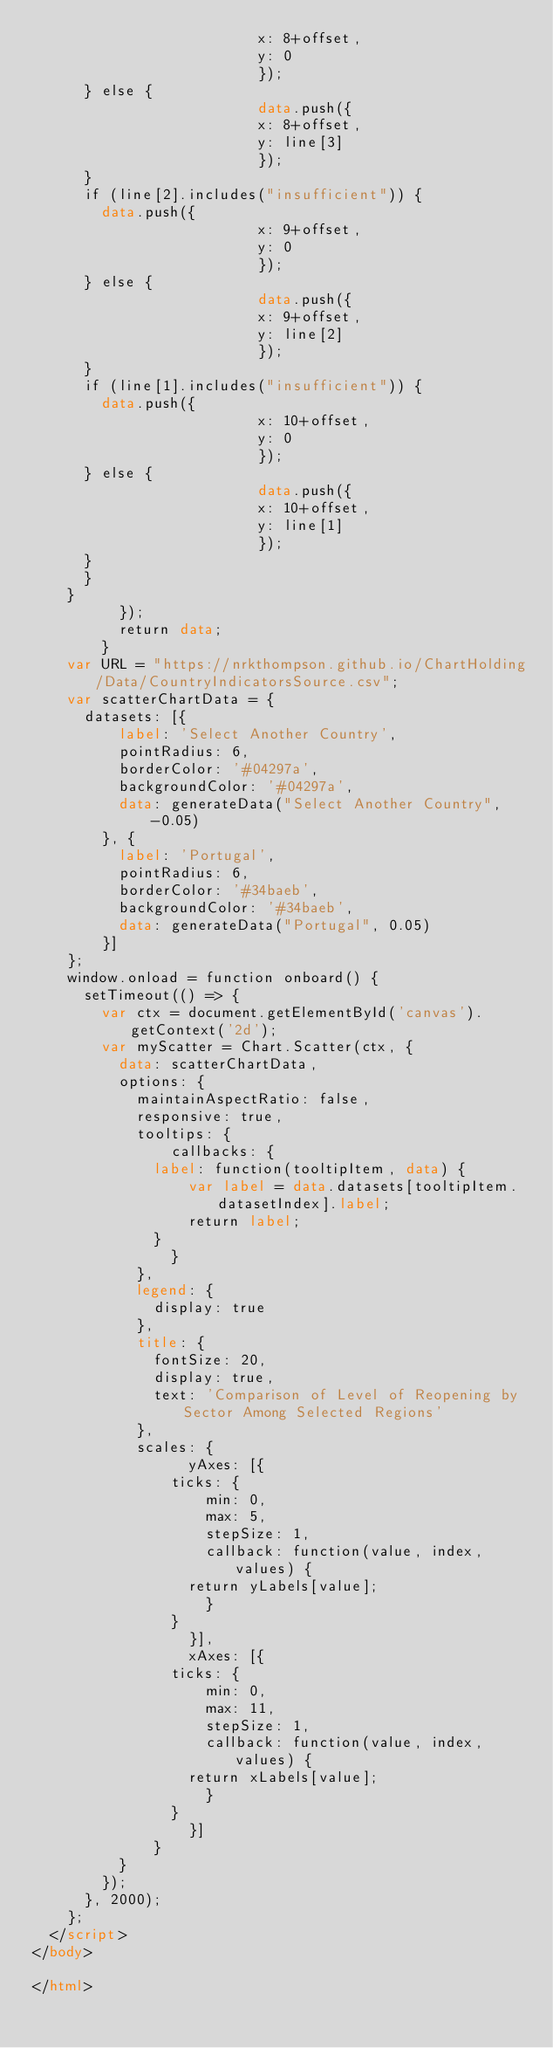Convert code to text. <code><loc_0><loc_0><loc_500><loc_500><_HTML_>                        	x: 8+offset,
                        	y: 0
                        	});
			} else {
                        	data.push({
                        	x: 8+offset,
                        	y: line[3]
                        	});
			}
			if (line[2].includes("insufficient")) {
				data.push({
                        	x: 9+offset,
                        	y: 0
                        	});
			} else {
                        	data.push({
                        	x: 9+offset,
                        	y: line[2]
                        	});
			}
			if (line[1].includes("insufficient")) {
				data.push({
                        	x: 10+offset,
                        	y: 0
                        	});
			} else {
                        	data.push({
                        	x: 10+offset,
                        	y: line[1]
                        	});
			}
		  }
		}
          });
          return data;
        }
    var URL = "https://nrkthompson.github.io/ChartHolding/Data/CountryIndicatorsSource.csv";
		var scatterChartData = {
			datasets: [{
					label: 'Select Another Country',
					pointRadius: 6,
					borderColor: '#04297a',
					backgroundColor: '#04297a',
					data: generateData("Select Another Country", -0.05)
				}, {
					label: 'Portugal',
					pointRadius: 6,
					borderColor: '#34baeb',
					backgroundColor: '#34baeb',
					data: generateData("Portugal", 0.05)
				}]
		};
		window.onload = function onboard() {
			setTimeout(() => { 
				var ctx = document.getElementById('canvas').getContext('2d');
				var myScatter = Chart.Scatter(ctx, {
					data: scatterChartData,
					options: {
						maintainAspectRatio: false,
						responsive: true,
						tooltips: {
						    callbacks: {
							label: function(tooltipItem, data) {
							    var label = data.datasets[tooltipItem.datasetIndex].label;
							    return label;
							}
						    }
						},
						legend: {
							display: true
						},
						title: {
							fontSize: 20,
							display: true,
							text: 'Comparison of Level of Reopening by Sector Among Selected Regions'
						},
						scales: {
						      yAxes: [{
							  ticks: {
							      min: 0,
							      max: 5,
							      stepSize: 1,
							      callback: function(value, index, values) {
								  return yLabels[value];
							      }
							  }
						      }],
						      xAxes: [{
							  ticks: {
							      min: 0,
							      max: 11,
							      stepSize: 1,
							      callback: function(value, index, values) {
								  return xLabels[value];
							      }
							  }
						      }]
						  }
					}
				});
			}, 2000);
		};
	</script>
</body>

</html></code> 